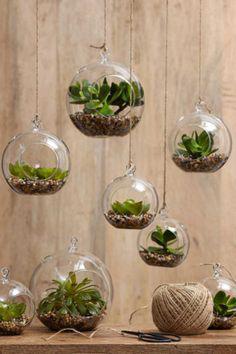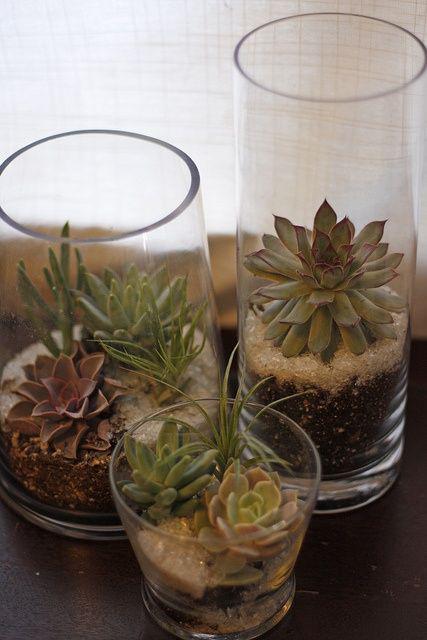The first image is the image on the left, the second image is the image on the right. For the images displayed, is the sentence "There are at least two square glass holders with small green shrubbery and rock." factually correct? Answer yes or no. No. The first image is the image on the left, the second image is the image on the right. For the images shown, is this caption "There are more containers holding plants in the image on the left." true? Answer yes or no. Yes. 